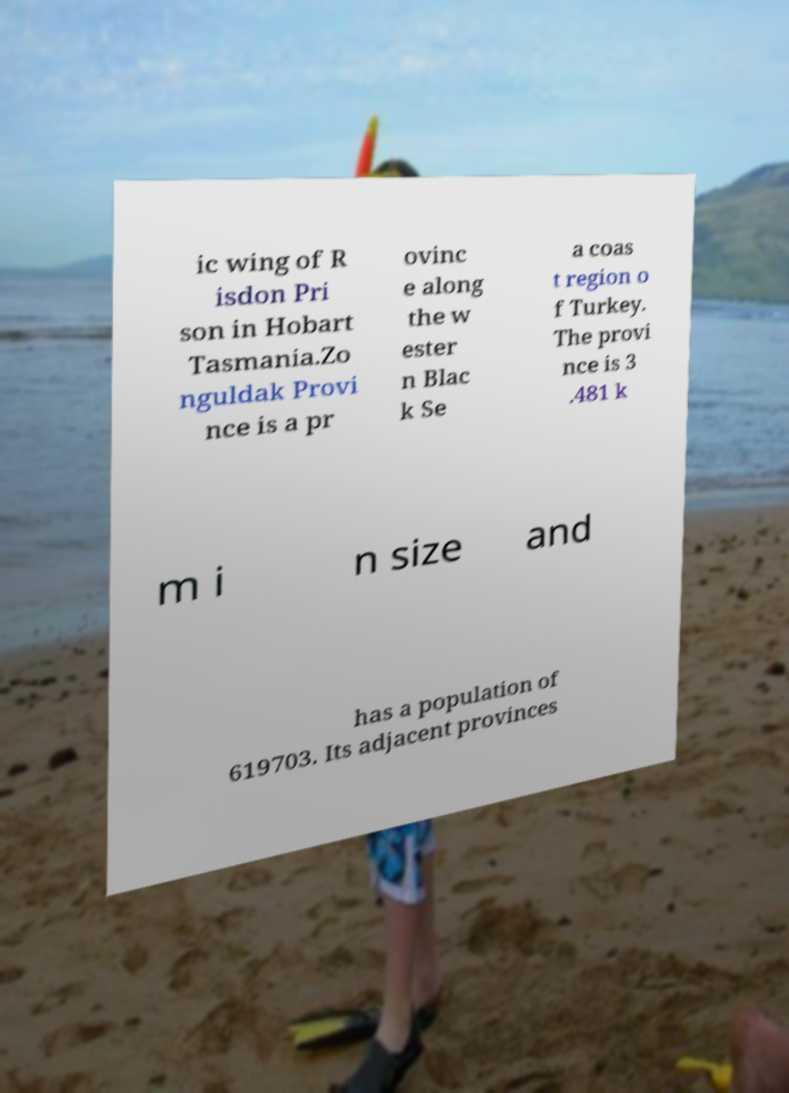I need the written content from this picture converted into text. Can you do that? ic wing of R isdon Pri son in Hobart Tasmania.Zo nguldak Provi nce is a pr ovinc e along the w ester n Blac k Se a coas t region o f Turkey. The provi nce is 3 .481 k m i n size and has a population of 619703. Its adjacent provinces 